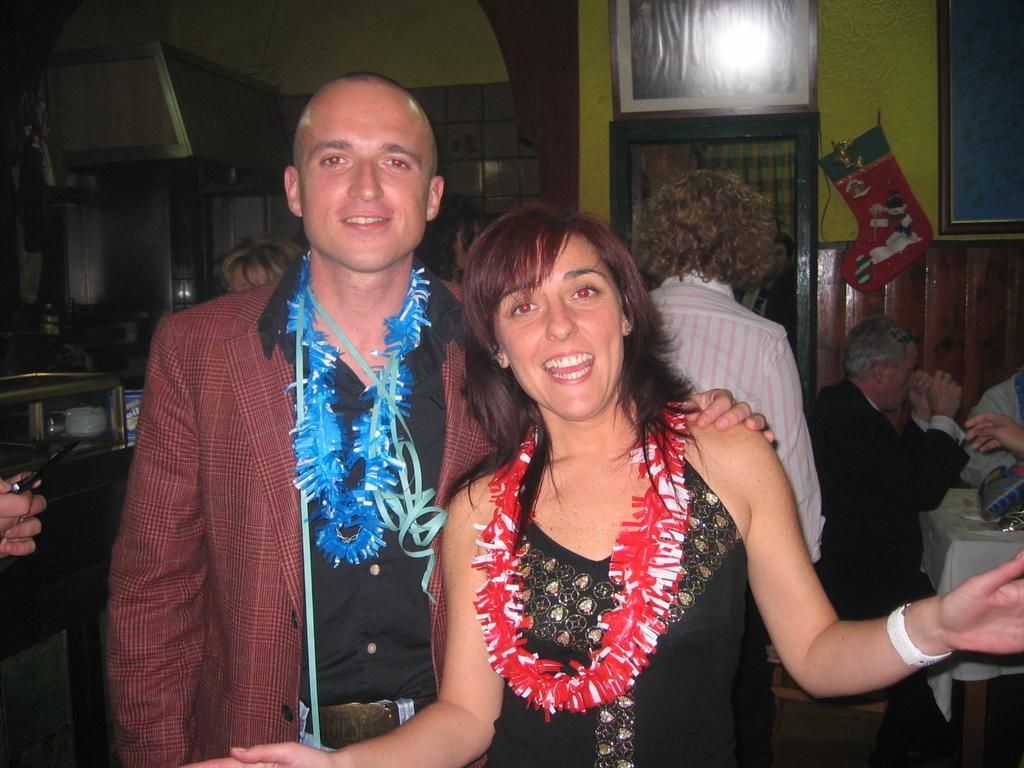Please provide a concise description of this image. In this image I can see number of people and in the front I can see two colourful things around two people's necks. On the left side of this image I can see one person is holding a phone and on the right side of this image I can see a table and on it I can see a white colour table cloth and few other stuffs. In the background I can see a frame and a red colour thing on the wall. 